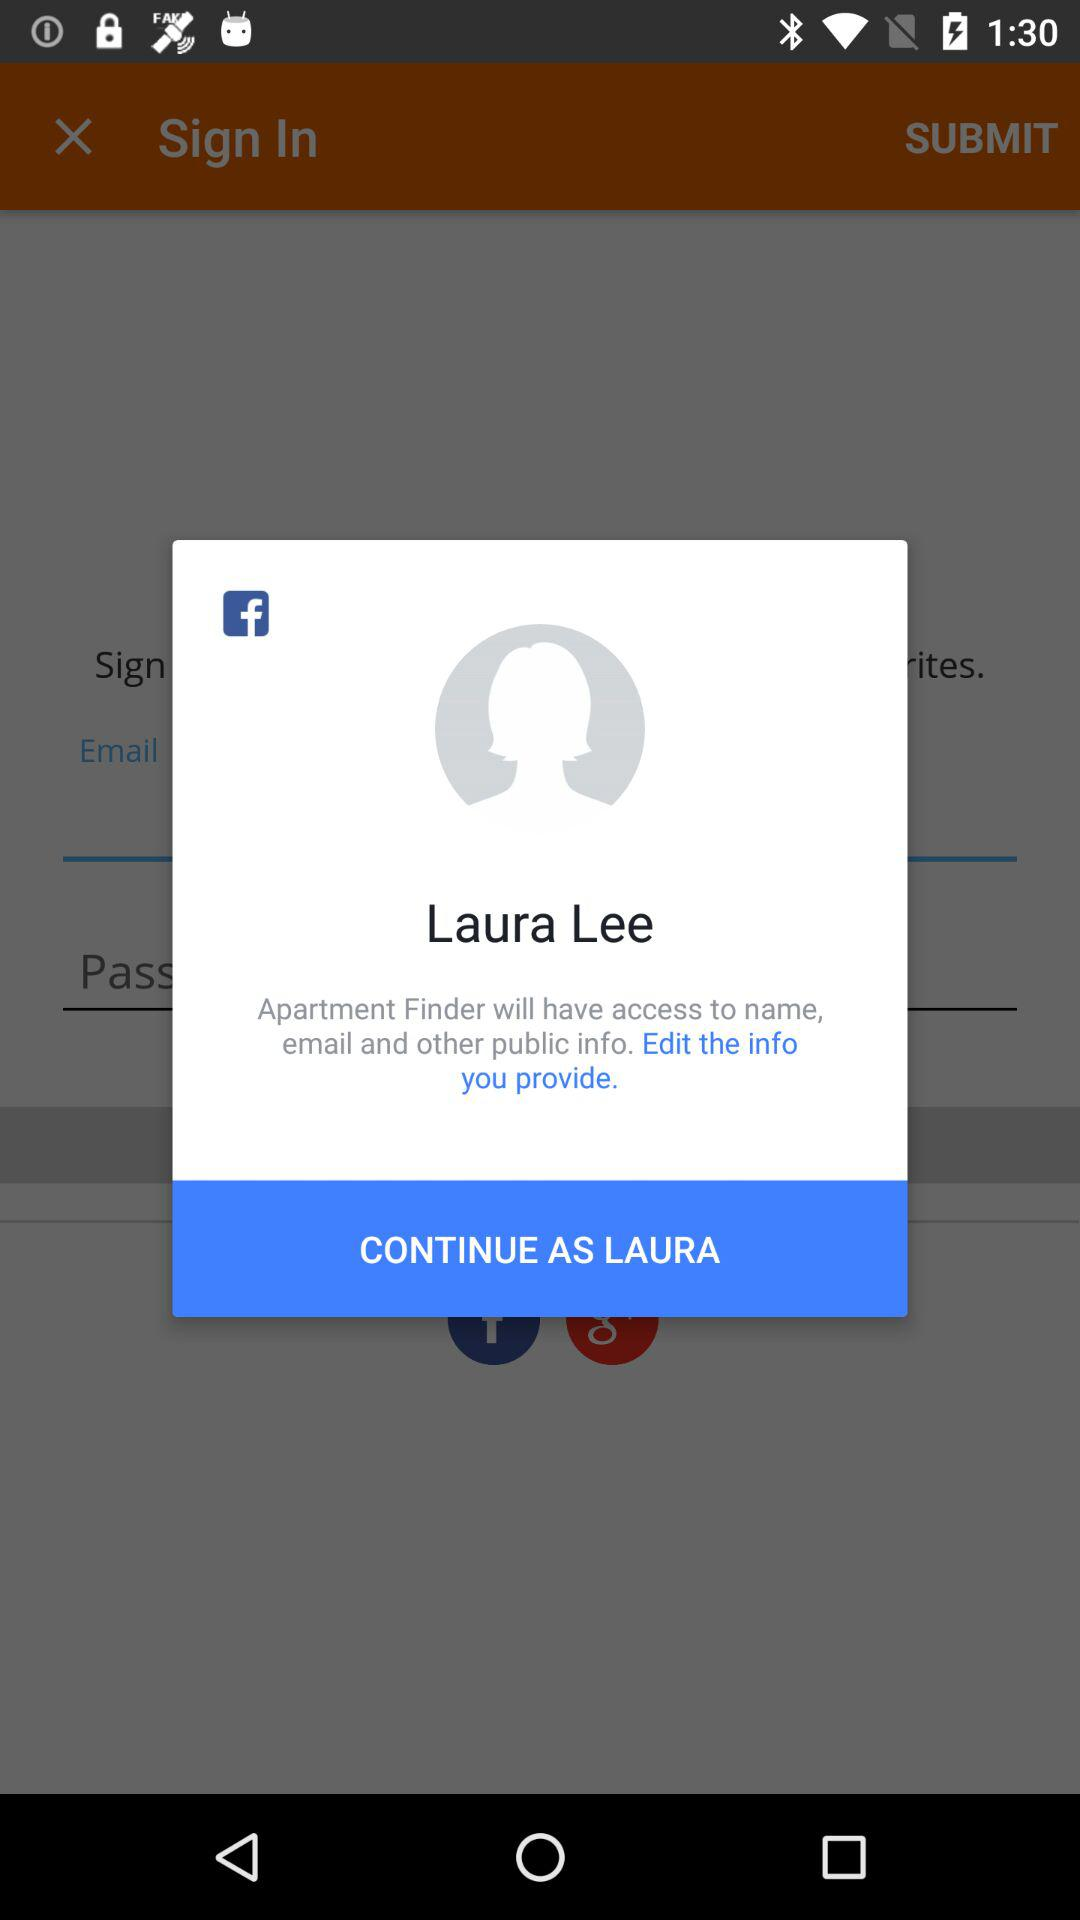What is the user name used for signing in? The user name is Laura Lee. 